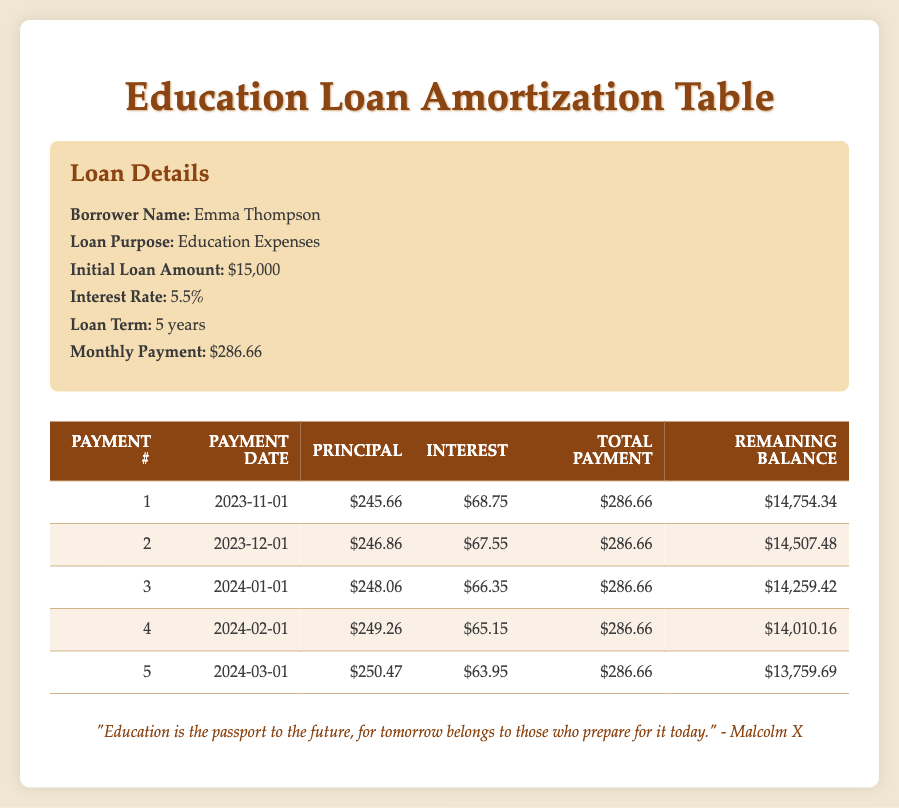What is the interest payment for the second month? The interest payment for the second month is listed in the second row under "Interest". It shows $67.55.
Answer: 67.55 What is the remaining balance after the first payment? The remaining balance after the first payment is provided in the first row under "Remaining Balance". It indicates $14,754.34.
Answer: 14,754.34 What is the total principal paid in the first five months? To find the total principal paid, sum the principal payments for the first five months: 245.66 + 246.86 + 248.06 + 249.26 + 250.47 = 1,240.31.
Answer: 1,240.31 Is the interest payment decreasing over the first five months? By looking at the "Interest" column for each of the first five payments, the amounts are 68.75, 67.55, 66.35, 65.15, and 63.95, which clearly show a decreasing trend.
Answer: Yes How much higher is the monthly payment than the interest payment for the first month? The monthly payment is $286.66 while the interest payment for the first month is $68.75. The difference is computed as 286.66 - 68.75 = 217.91.
Answer: 217.91 What is the average principal payment over the first five months? The average principal payment is calculated by summing the principal payments (245.66 + 246.86 + 248.06 + 249.26 + 250.47 = 1,240.31) and then dividing by the number of payments (5), resulting in an average of 1,240.31 / 5 = 248.06.
Answer: 248.06 Does the loan purpose indicate that the borrower is using the loan for personal expenses? The loan purpose specified is "Education Expenses," which does not classify as personal expenses but indicates it is intended for educational use.
Answer: No What was the total payment made by the borrower in the third month? The total payment for the third month is directly taken from the "Total Payment" column in the respective row for the third month, which shows $286.66.
Answer: 286.66 